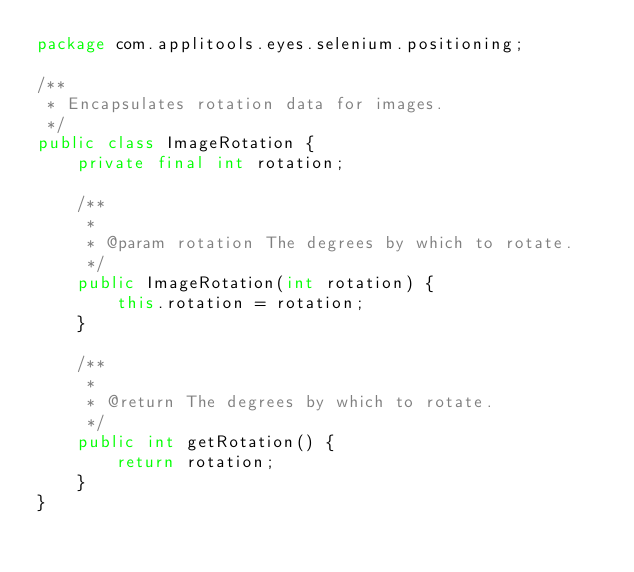Convert code to text. <code><loc_0><loc_0><loc_500><loc_500><_Java_>package com.applitools.eyes.selenium.positioning;

/**
 * Encapsulates rotation data for images.
 */
public class ImageRotation {
    private final int rotation;

    /**
     *
     * @param rotation The degrees by which to rotate.
     */
    public ImageRotation(int rotation) {
        this.rotation = rotation;
    }

    /**
     *
     * @return The degrees by which to rotate.
     */
    public int getRotation() {
        return rotation;
    }
}
</code> 